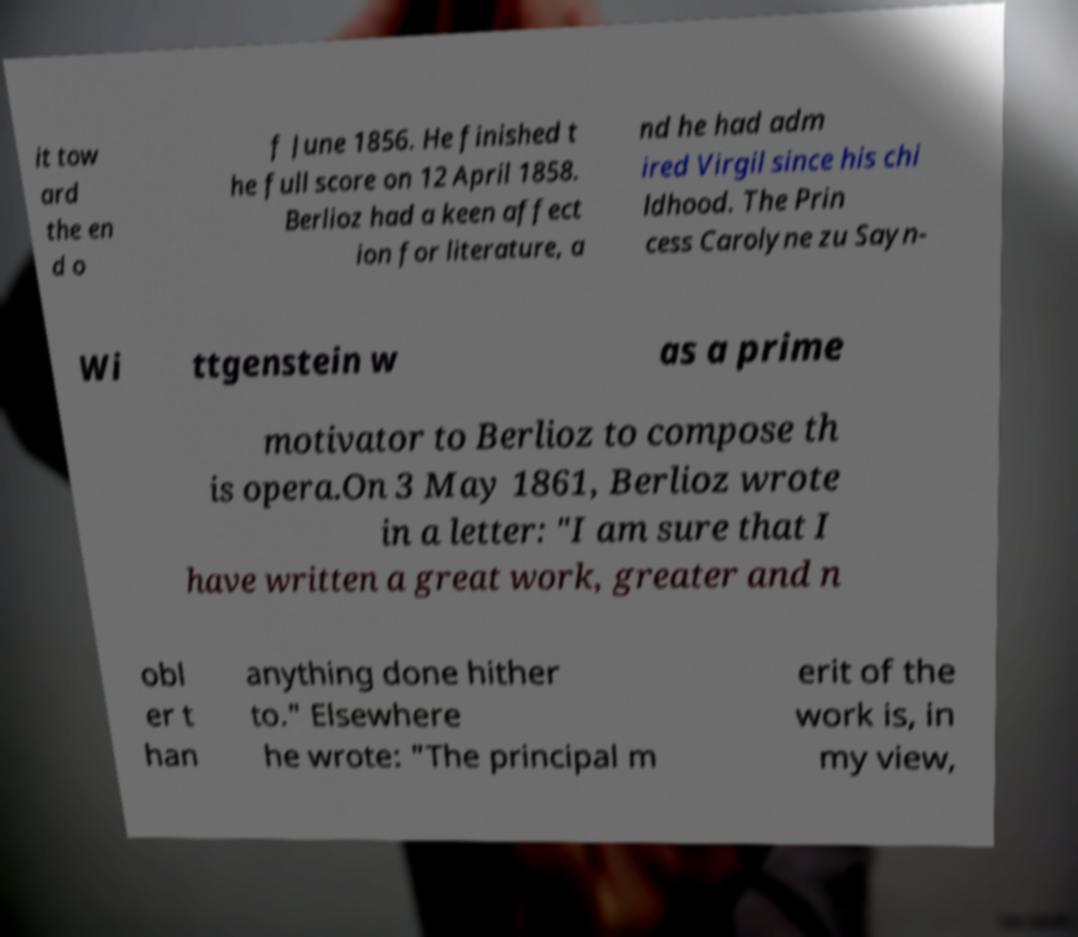There's text embedded in this image that I need extracted. Can you transcribe it verbatim? it tow ard the en d o f June 1856. He finished t he full score on 12 April 1858. Berlioz had a keen affect ion for literature, a nd he had adm ired Virgil since his chi ldhood. The Prin cess Carolyne zu Sayn- Wi ttgenstein w as a prime motivator to Berlioz to compose th is opera.On 3 May 1861, Berlioz wrote in a letter: "I am sure that I have written a great work, greater and n obl er t han anything done hither to." Elsewhere he wrote: "The principal m erit of the work is, in my view, 